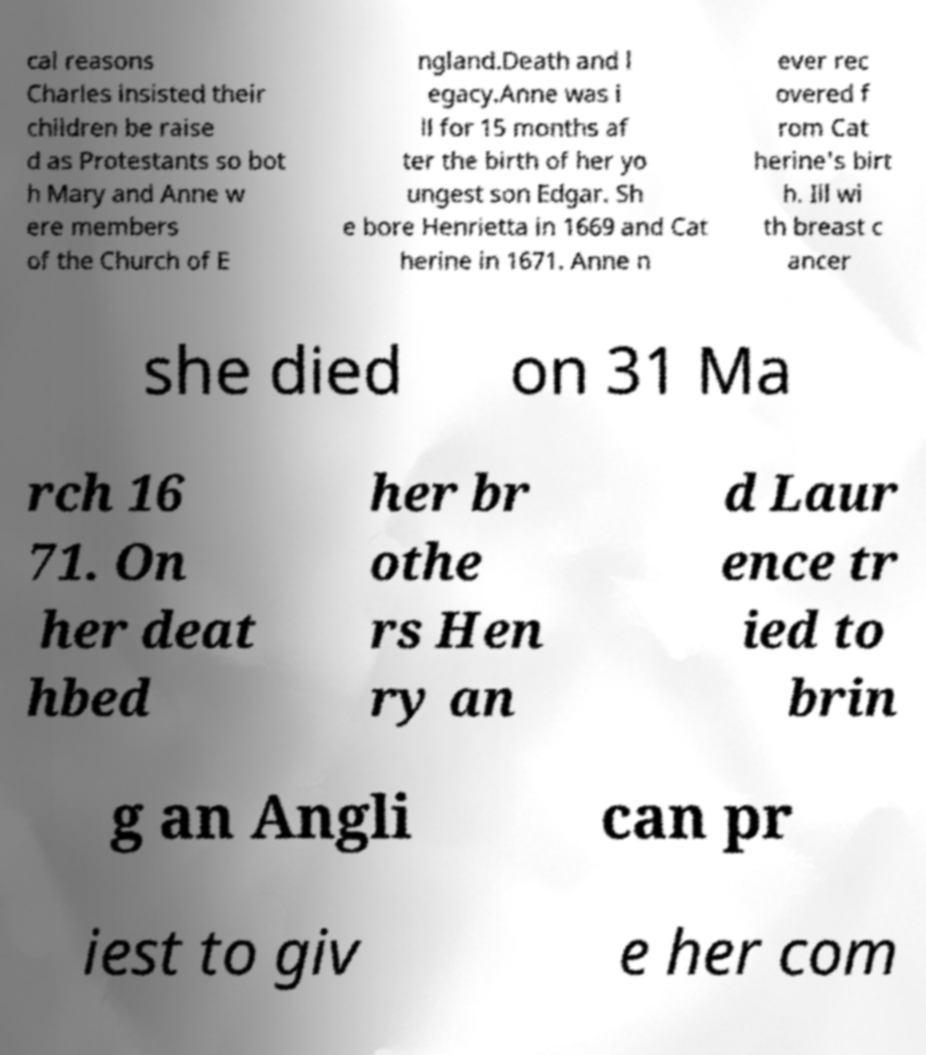I need the written content from this picture converted into text. Can you do that? cal reasons Charles insisted their children be raise d as Protestants so bot h Mary and Anne w ere members of the Church of E ngland.Death and l egacy.Anne was i ll for 15 months af ter the birth of her yo ungest son Edgar. Sh e bore Henrietta in 1669 and Cat herine in 1671. Anne n ever rec overed f rom Cat herine's birt h. Ill wi th breast c ancer she died on 31 Ma rch 16 71. On her deat hbed her br othe rs Hen ry an d Laur ence tr ied to brin g an Angli can pr iest to giv e her com 